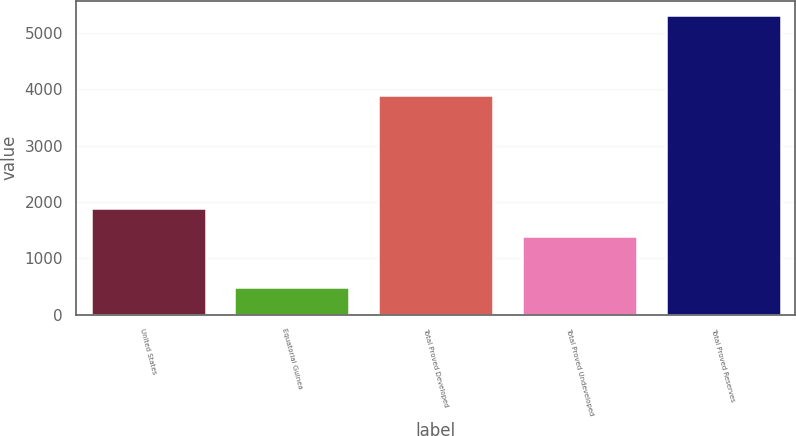Convert chart to OTSL. <chart><loc_0><loc_0><loc_500><loc_500><bar_chart><fcel>United States<fcel>Equatorial Guinea<fcel>Total Proved Developed<fcel>Total Proved Undeveloped<fcel>Total Proved Reserves<nl><fcel>1887.2<fcel>486<fcel>3903<fcel>1405<fcel>5308<nl></chart> 